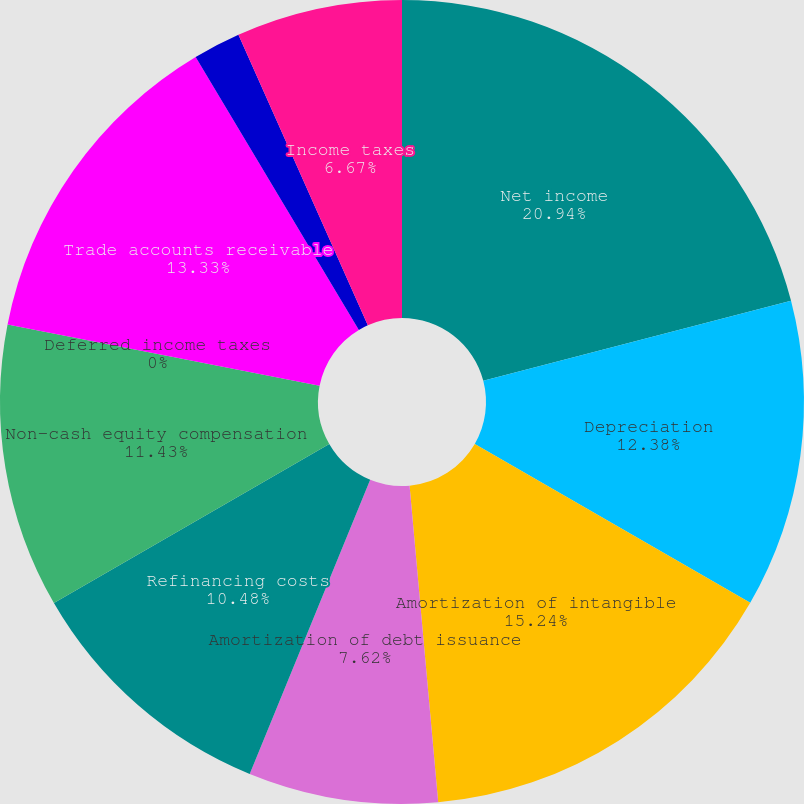Convert chart to OTSL. <chart><loc_0><loc_0><loc_500><loc_500><pie_chart><fcel>Net income<fcel>Depreciation<fcel>Amortization of intangible<fcel>Amortization of debt issuance<fcel>Refinancing costs<fcel>Non-cash equity compensation<fcel>Deferred income taxes<fcel>Trade accounts receivable<fcel>Inventories<fcel>Income taxes<nl><fcel>20.95%<fcel>12.38%<fcel>15.24%<fcel>7.62%<fcel>10.48%<fcel>11.43%<fcel>0.0%<fcel>13.33%<fcel>1.91%<fcel>6.67%<nl></chart> 